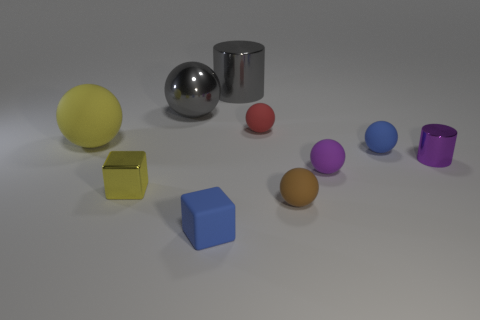What number of other objects are the same size as the brown rubber object?
Your answer should be compact. 6. Is the color of the big matte ball the same as the tiny metallic block?
Ensure brevity in your answer.  Yes. There is a large object in front of the red rubber ball left of the tiny purple object that is right of the purple sphere; what is its shape?
Offer a very short reply. Sphere. What number of objects are small rubber things behind the tiny blue sphere or objects that are right of the yellow rubber thing?
Your response must be concise. 9. How big is the gray metallic thing behind the big metal thing in front of the big shiny cylinder?
Your answer should be compact. Large. Does the small metallic thing that is to the left of the red matte thing have the same color as the large rubber sphere?
Your answer should be very brief. Yes. Are there any large things that have the same shape as the small brown object?
Offer a very short reply. Yes. What color is the rubber block that is the same size as the red rubber ball?
Offer a terse response. Blue. What is the size of the yellow thing behind the yellow block?
Provide a short and direct response. Large. Is there a small rubber thing on the right side of the tiny blue rubber thing that is in front of the brown thing?
Your response must be concise. Yes. 